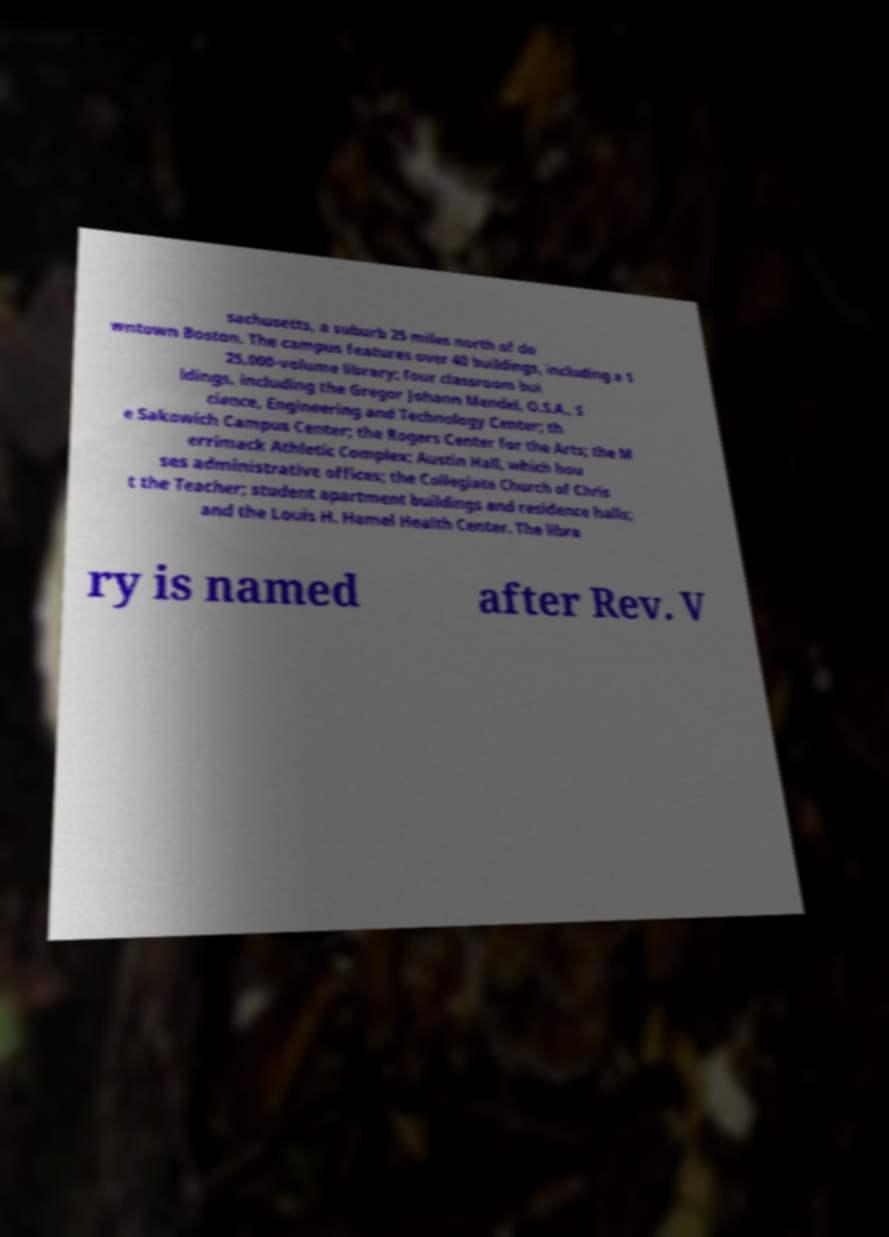For documentation purposes, I need the text within this image transcribed. Could you provide that? sachusetts, a suburb 25 miles north of do wntown Boston. The campus features over 40 buildings, including a 1 25,000-volume library; four classroom bui ldings, including the Gregor Johann Mendel, O.S.A., S cience, Engineering and Technology Center; th e Sakowich Campus Center; the Rogers Center for the Arts; the M errimack Athletic Complex; Austin Hall, which hou ses administrative offices; the Collegiate Church of Chris t the Teacher; student apartment buildings and residence halls; and the Louis H. Hamel Health Center. The libra ry is named after Rev. V 